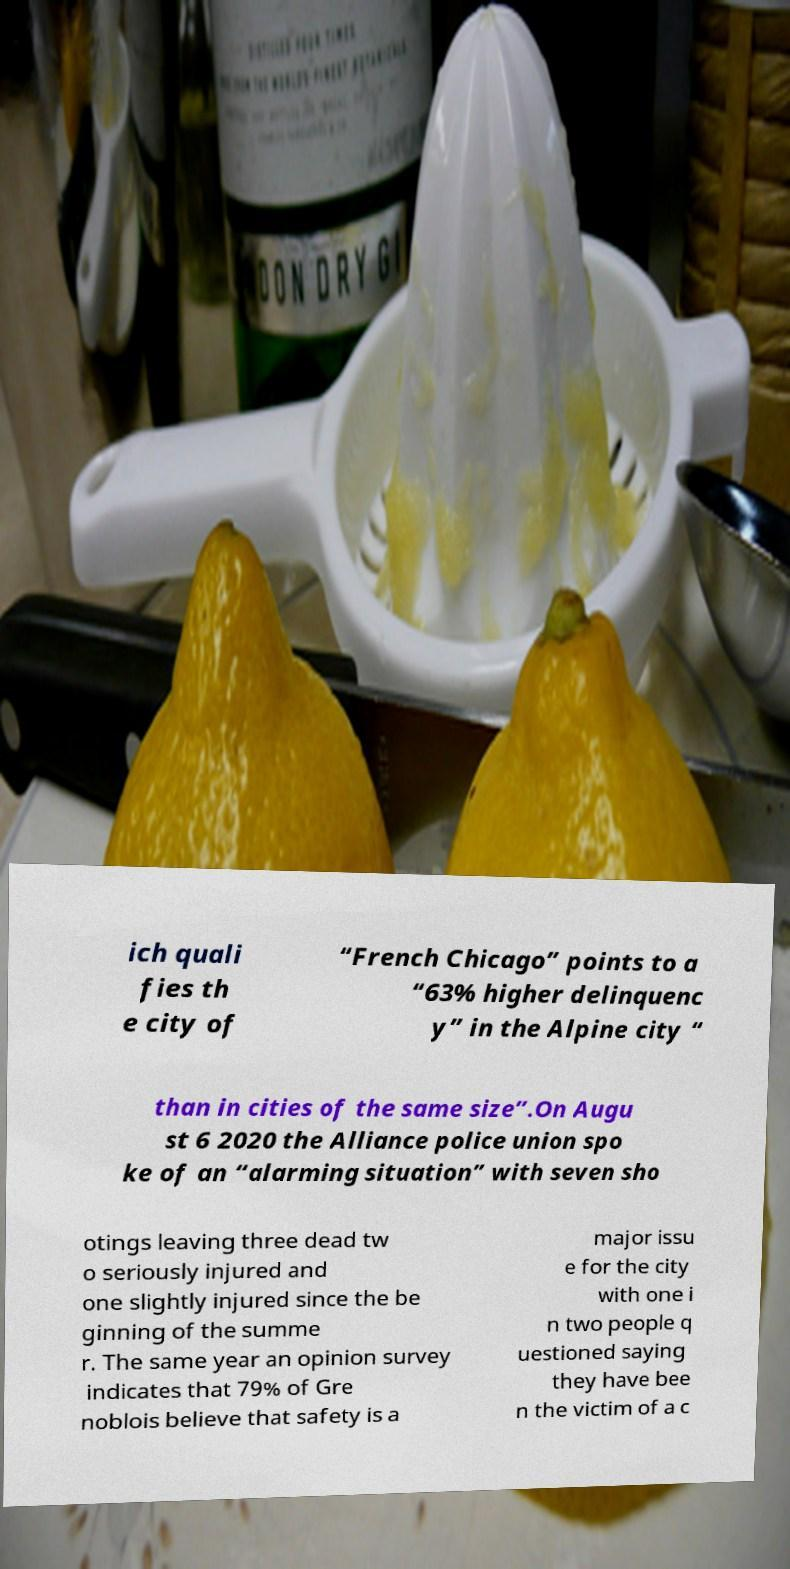Please read and relay the text visible in this image. What does it say? ich quali fies th e city of “French Chicago” points to a “63% higher delinquenc y” in the Alpine city “ than in cities of the same size”.On Augu st 6 2020 the Alliance police union spo ke of an “alarming situation” with seven sho otings leaving three dead tw o seriously injured and one slightly injured since the be ginning of the summe r. The same year an opinion survey indicates that 79% of Gre noblois believe that safety is a major issu e for the city with one i n two people q uestioned saying they have bee n the victim of a c 